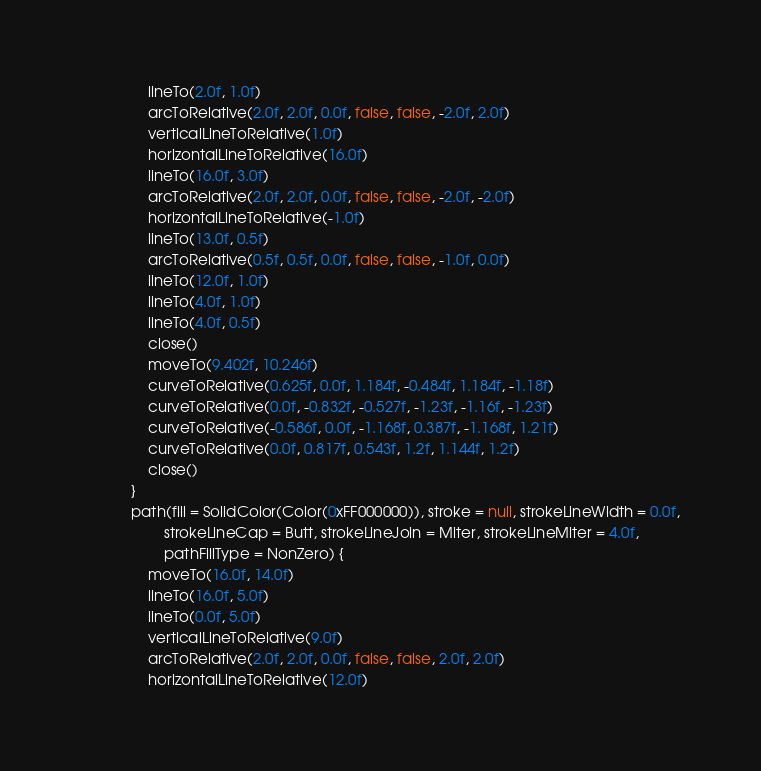Convert code to text. <code><loc_0><loc_0><loc_500><loc_500><_Kotlin_>                lineTo(2.0f, 1.0f)
                arcToRelative(2.0f, 2.0f, 0.0f, false, false, -2.0f, 2.0f)
                verticalLineToRelative(1.0f)
                horizontalLineToRelative(16.0f)
                lineTo(16.0f, 3.0f)
                arcToRelative(2.0f, 2.0f, 0.0f, false, false, -2.0f, -2.0f)
                horizontalLineToRelative(-1.0f)
                lineTo(13.0f, 0.5f)
                arcToRelative(0.5f, 0.5f, 0.0f, false, false, -1.0f, 0.0f)
                lineTo(12.0f, 1.0f)
                lineTo(4.0f, 1.0f)
                lineTo(4.0f, 0.5f)
                close()
                moveTo(9.402f, 10.246f)
                curveToRelative(0.625f, 0.0f, 1.184f, -0.484f, 1.184f, -1.18f)
                curveToRelative(0.0f, -0.832f, -0.527f, -1.23f, -1.16f, -1.23f)
                curveToRelative(-0.586f, 0.0f, -1.168f, 0.387f, -1.168f, 1.21f)
                curveToRelative(0.0f, 0.817f, 0.543f, 1.2f, 1.144f, 1.2f)
                close()
            }
            path(fill = SolidColor(Color(0xFF000000)), stroke = null, strokeLineWidth = 0.0f,
                    strokeLineCap = Butt, strokeLineJoin = Miter, strokeLineMiter = 4.0f,
                    pathFillType = NonZero) {
                moveTo(16.0f, 14.0f)
                lineTo(16.0f, 5.0f)
                lineTo(0.0f, 5.0f)
                verticalLineToRelative(9.0f)
                arcToRelative(2.0f, 2.0f, 0.0f, false, false, 2.0f, 2.0f)
                horizontalLineToRelative(12.0f)</code> 